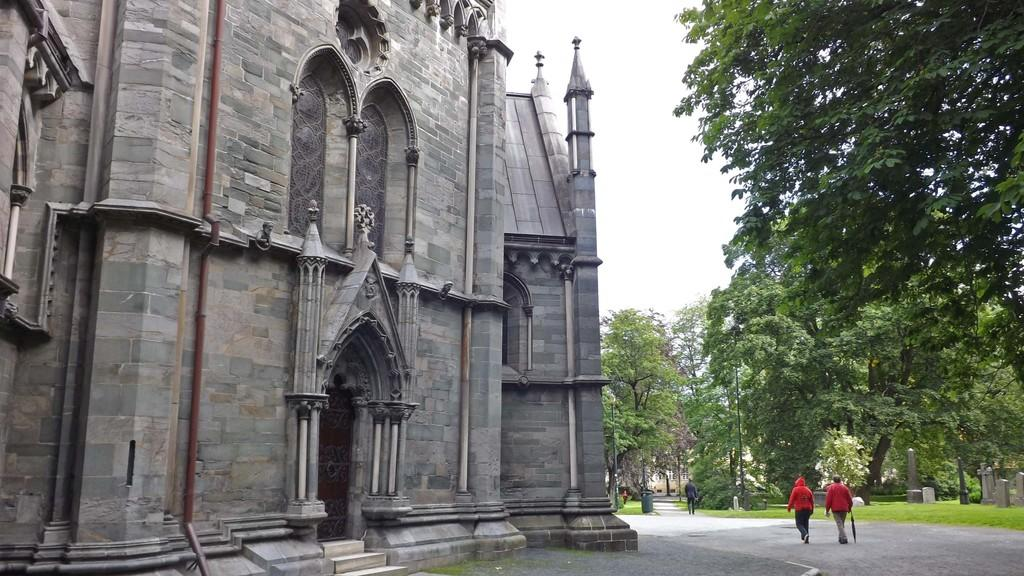Who or what can be seen in the image? There are people in the image. What type of terrain is visible in the image? The ground is visible in the image, and there is grass present. What is the setting of the image? The image is set in a graveyard, as indicated by the presence of gravestones. What other objects or structures can be seen in the image? Trees, a dustbin, and a building are present in the image. What is visible in the background of the image? The sky is visible in the background of the image. What type of disease is being treated in the library in the image? There is no library or disease treatment present in the image; it is set in a graveyard with people, trees, a dustbin, and a building. 